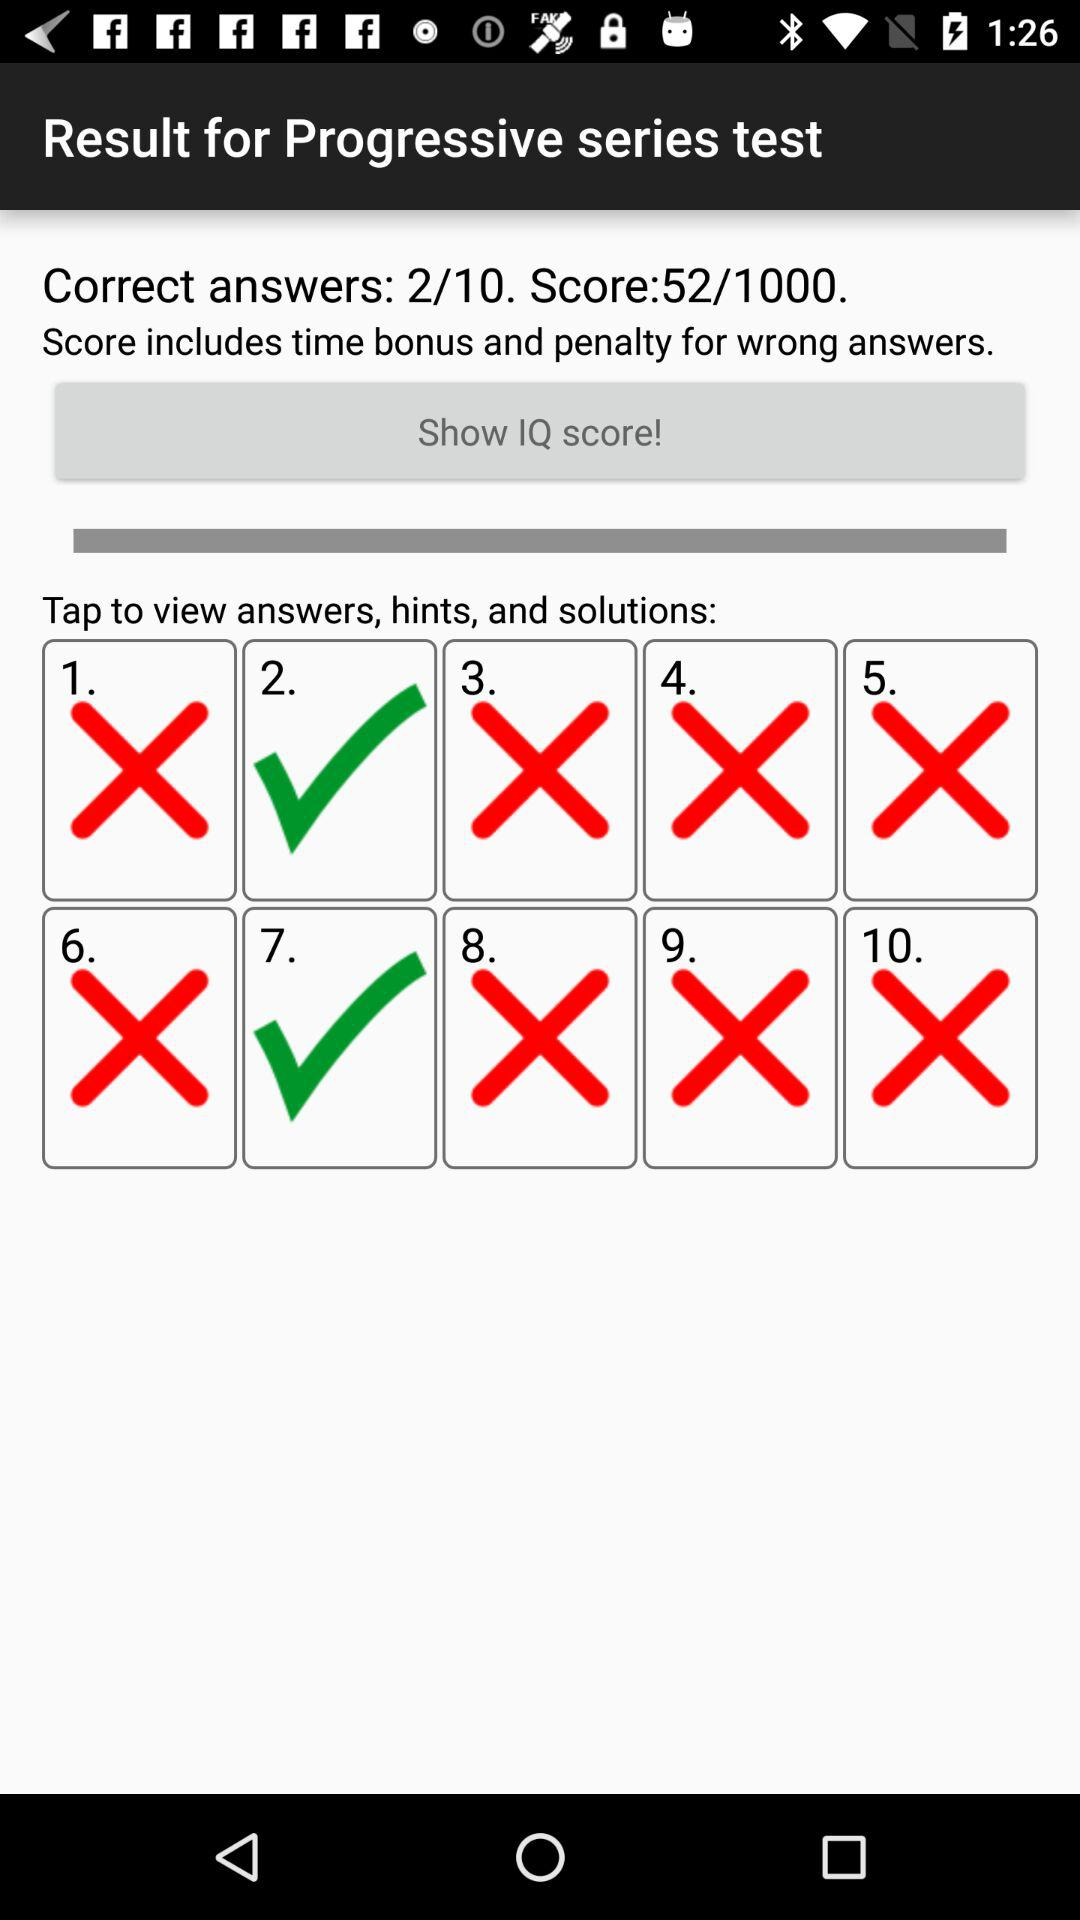What is the count of correct answers? The count of correct answers is 2. 